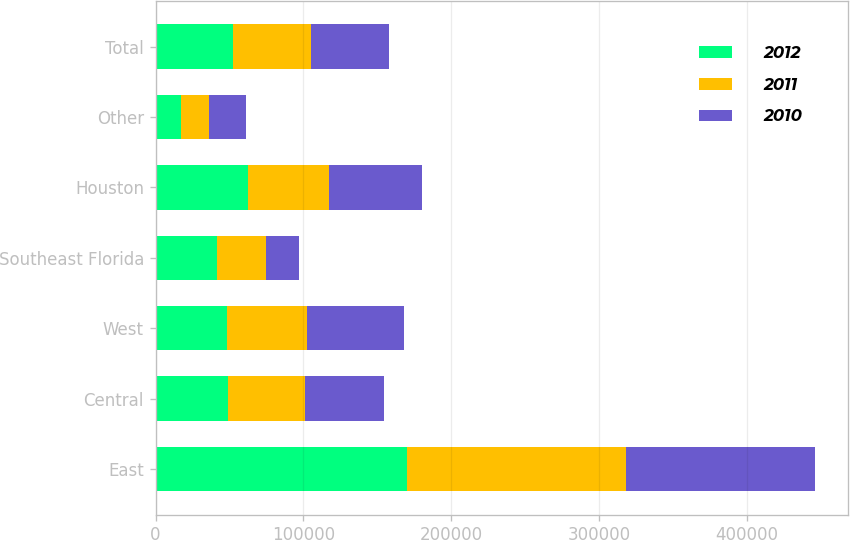Convert chart to OTSL. <chart><loc_0><loc_0><loc_500><loc_500><stacked_bar_chart><ecel><fcel>East<fcel>Central<fcel>West<fcel>Southeast Florida<fcel>Houston<fcel>Other<fcel>Total<nl><fcel>2012<fcel>169779<fcel>49028<fcel>48341<fcel>41529<fcel>62497<fcel>17050<fcel>52575.5<nl><fcel>2011<fcel>148424<fcel>52117<fcel>54000<fcel>33092<fcel>54680<fcel>19421<fcel>52575.5<nl><fcel>2010<fcel>127592<fcel>53034<fcel>65988<fcel>22248<fcel>63255<fcel>24370<fcel>52575.5<nl></chart> 